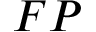Convert formula to latex. <formula><loc_0><loc_0><loc_500><loc_500>F P</formula> 